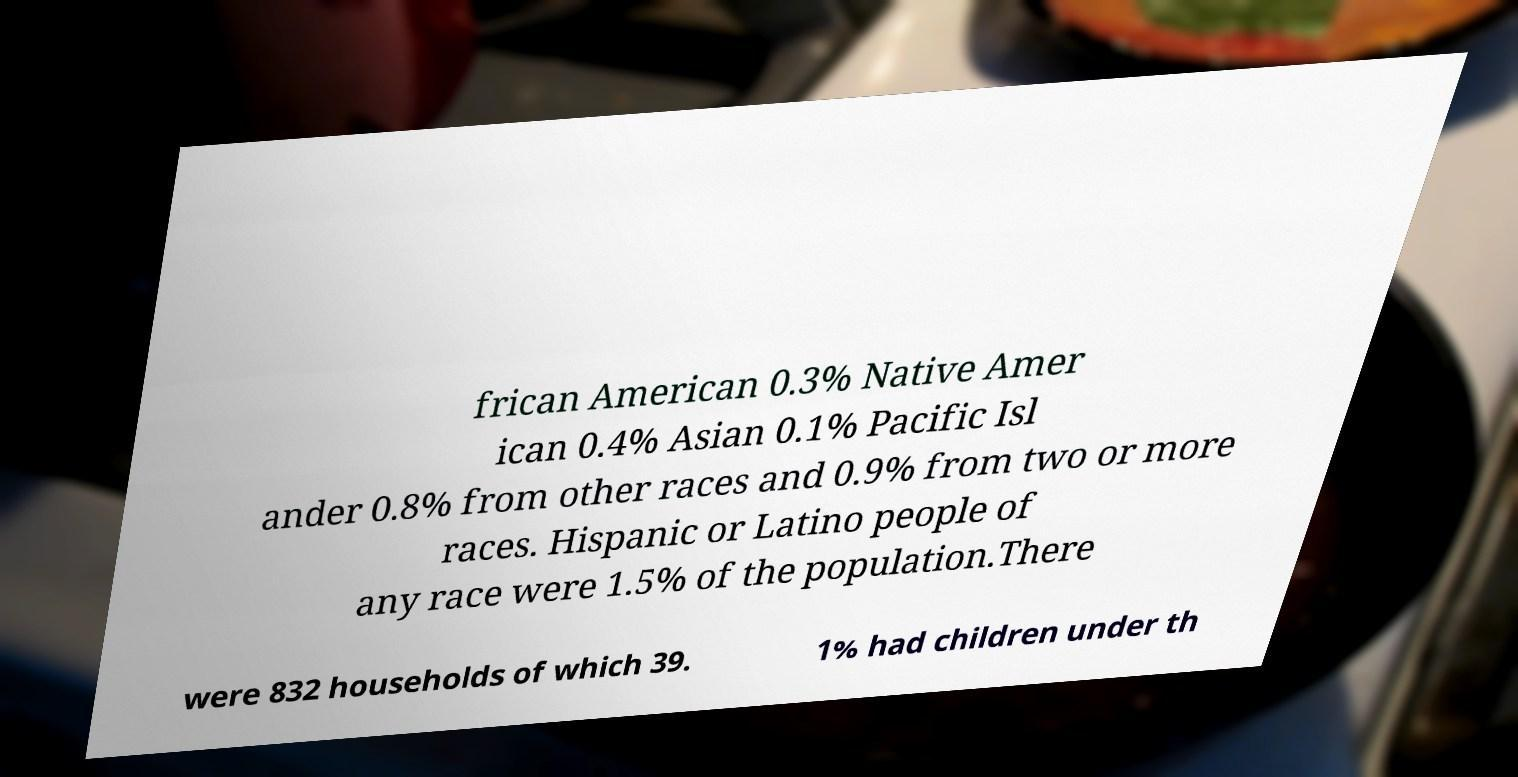What messages or text are displayed in this image? I need them in a readable, typed format. frican American 0.3% Native Amer ican 0.4% Asian 0.1% Pacific Isl ander 0.8% from other races and 0.9% from two or more races. Hispanic or Latino people of any race were 1.5% of the population.There were 832 households of which 39. 1% had children under th 